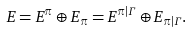Convert formula to latex. <formula><loc_0><loc_0><loc_500><loc_500>E = E ^ { \pi } \oplus E _ { \pi } = E ^ { \pi | \Gamma } \oplus E _ { \pi | \Gamma } .</formula> 